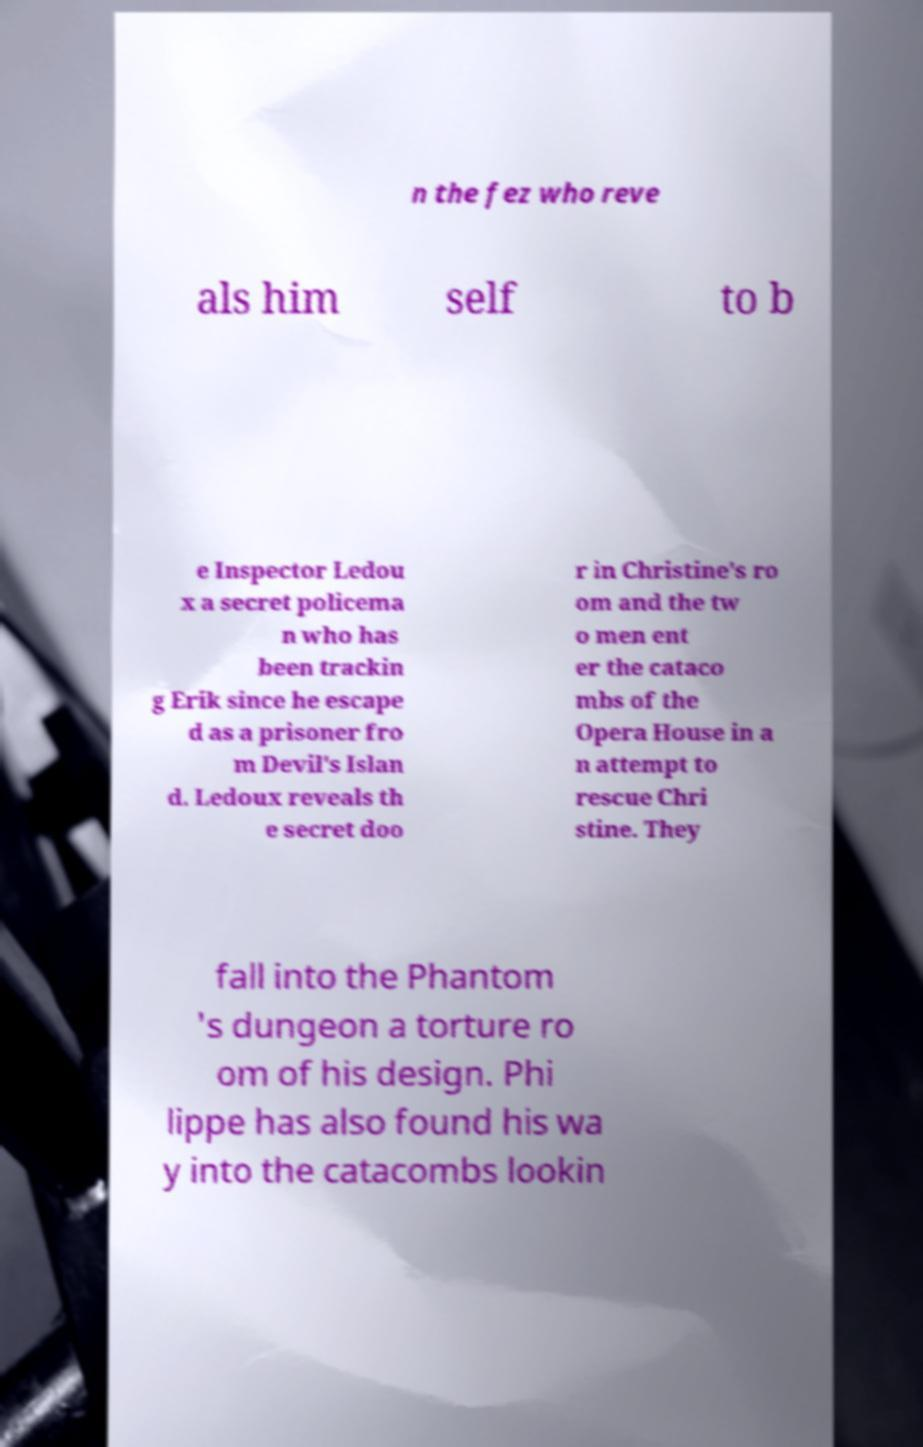Could you assist in decoding the text presented in this image and type it out clearly? n the fez who reve als him self to b e Inspector Ledou x a secret policema n who has been trackin g Erik since he escape d as a prisoner fro m Devil's Islan d. Ledoux reveals th e secret doo r in Christine's ro om and the tw o men ent er the cataco mbs of the Opera House in a n attempt to rescue Chri stine. They fall into the Phantom 's dungeon a torture ro om of his design. Phi lippe has also found his wa y into the catacombs lookin 